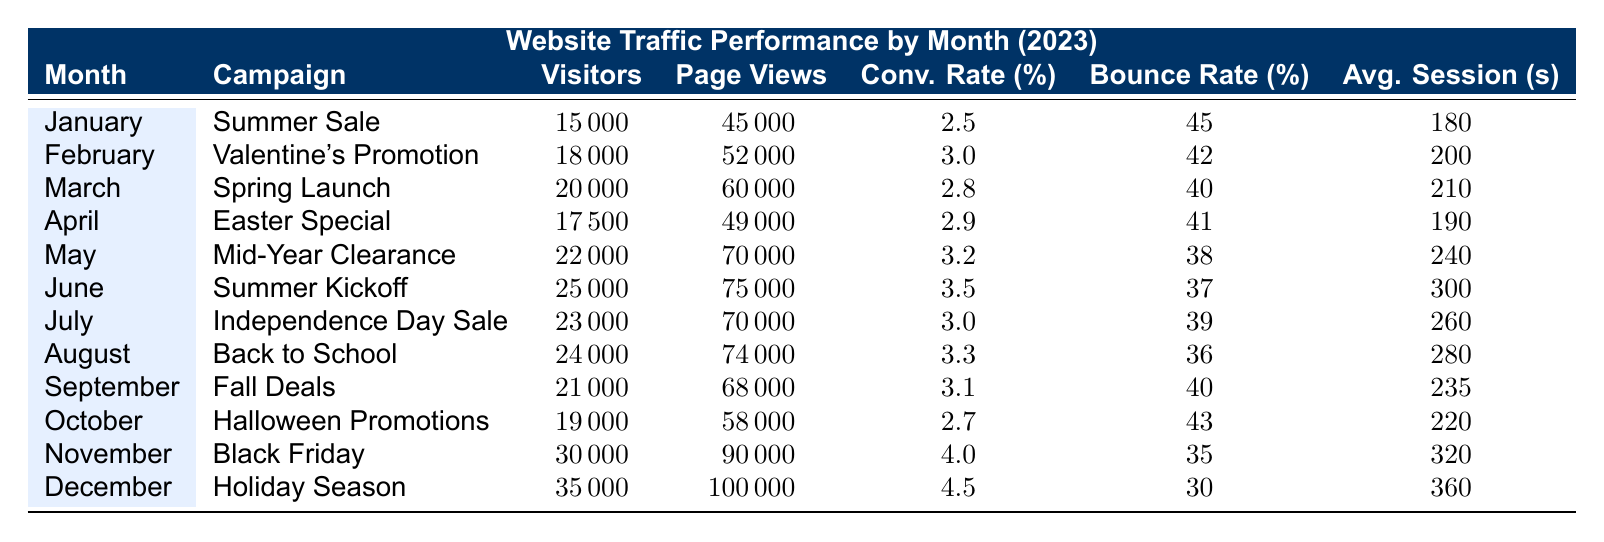What was the total number of visitors in December? According to the table, the number of visitors in December is listed as 35,000.
Answer: 35,000 Which campaign had the highest conversion rate? The conversion rates for each month are listed; comparing them, December has the highest conversion rate of 4.5 percent.
Answer: December How many page views did the "Summer Sale" campaign receive? In the table, the "Summer Sale" campaign in January has 45,000 page views.
Answer: 45,000 What is the average bounce rate for the campaigns from June to August? The bounce rates for June, July, and August are 37, 39, and 36 percent, respectively. The average bounce rate is (37 + 39 + 36) / 3 = 37.33 percent.
Answer: 37.33 Was there a month where visitors decreased compared to the previous month? By looking at the visitor counts from month to month, the counts show no decrease; visitor numbers only increased from January to June, and there are no decreases thereafter.
Answer: No What is the total number of page views for the first half of the year (January to June)? The page views for the first half are: January (45,000) + February (52,000) + March (60,000) + April (49,000) + May (70,000) + June (75,000). Adding these together gives 45,000 + 52,000 + 60,000 + 49,000 + 70,000 + 75,000 = 351,000.
Answer: 351,000 Which month had the longest average session duration? The average session durations for each month are provided, and December has the longest duration of 360 seconds.
Answer: December How does the conversion rate in November compare to the average conversion rate for all months? The conversion rate for November is 4.0 percent. Calculating the average conversion rate for all months (2.5 + 3.0 + 2.8 + 2.9 + 3.2 + 3.5 + 3.0 + 3.3 + 3.1 + 2.7 + 4.0 + 4.5) / 12 = 3.3 percent. Since 4.0 percent is greater than 3.3 percent, November's conversion rate is above average.
Answer: Above average What was the total visitor count from March to May? The visitor counts are: March (20,000), April (17,500), and May (22,000). Adding these gives 20,000 + 17,500 + 22,000 = 59,500.
Answer: 59,500 In which month did the visitors reach their peak, and what was the number? The peak visitor count is found in December, with a total of 35,000 visitors.
Answer: December, 35,000 